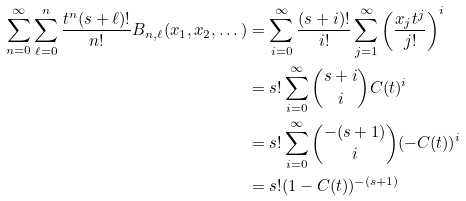Convert formula to latex. <formula><loc_0><loc_0><loc_500><loc_500>\sum _ { n = 0 } ^ { \infty } \sum _ { \ell = 0 } ^ { n } \frac { t ^ { n } ( s + \ell ) ! } { n ! } B _ { n , \ell } ( x _ { 1 } , x _ { 2 } , \dots ) & = \sum _ { i = 0 } ^ { \infty } \frac { ( s + i ) ! } { i ! } \sum _ { j = 1 } ^ { \infty } \left ( \frac { x _ { j } t ^ { j } } { j ! } \right ) ^ { i } \\ & = s ! \sum _ { i = 0 } ^ { \infty } \binom { s + i } { i } C ( t ) ^ { i } \\ & = s ! \sum _ { i = 0 } ^ { \infty } \binom { - ( s + 1 ) } { i } ( - C ( t ) ) ^ { i } \\ & = s ! ( 1 - C ( t ) ) ^ { - ( s + 1 ) }</formula> 